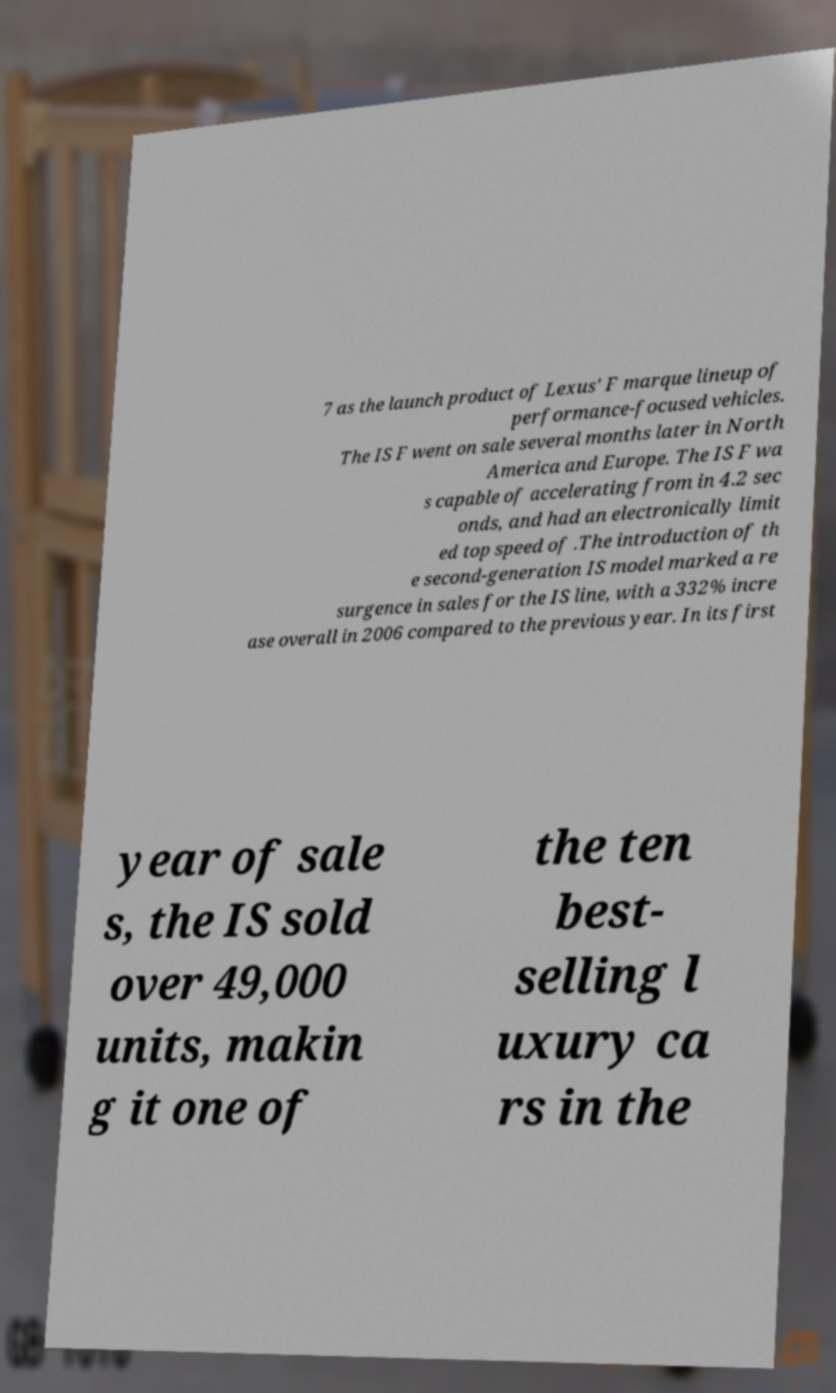Could you extract and type out the text from this image? 7 as the launch product of Lexus' F marque lineup of performance-focused vehicles. The IS F went on sale several months later in North America and Europe. The IS F wa s capable of accelerating from in 4.2 sec onds, and had an electronically limit ed top speed of .The introduction of th e second-generation IS model marked a re surgence in sales for the IS line, with a 332% incre ase overall in 2006 compared to the previous year. In its first year of sale s, the IS sold over 49,000 units, makin g it one of the ten best- selling l uxury ca rs in the 